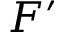<formula> <loc_0><loc_0><loc_500><loc_500>F ^ { \prime }</formula> 